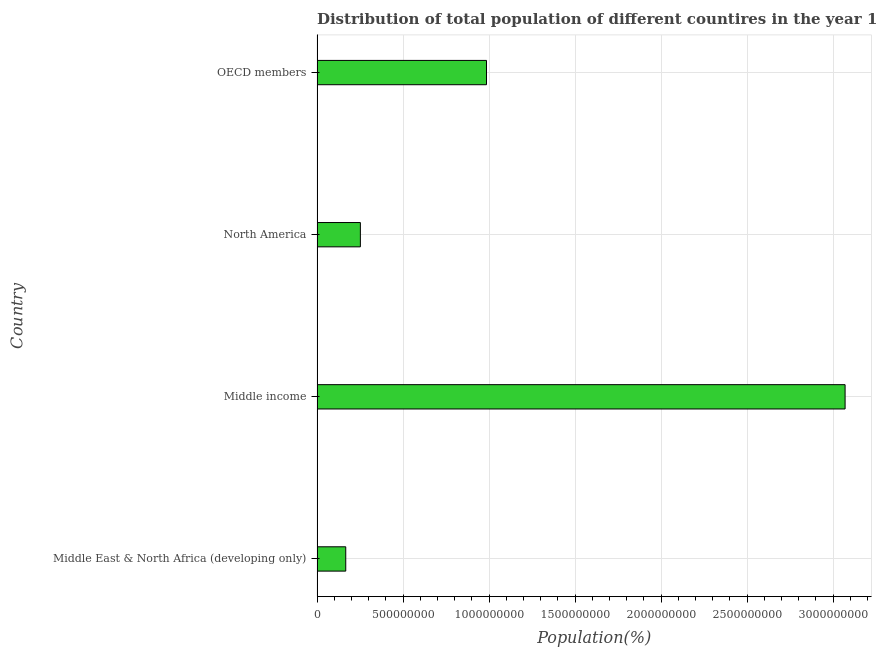Does the graph contain any zero values?
Keep it short and to the point. No. What is the title of the graph?
Offer a terse response. Distribution of total population of different countires in the year 1980. What is the label or title of the X-axis?
Your answer should be compact. Population(%). What is the label or title of the Y-axis?
Make the answer very short. Country. What is the population in Middle East & North Africa (developing only)?
Keep it short and to the point. 1.67e+08. Across all countries, what is the maximum population?
Keep it short and to the point. 3.07e+09. Across all countries, what is the minimum population?
Ensure brevity in your answer.  1.67e+08. In which country was the population minimum?
Make the answer very short. Middle East & North Africa (developing only). What is the sum of the population?
Offer a very short reply. 4.47e+09. What is the difference between the population in Middle East & North Africa (developing only) and OECD members?
Offer a very short reply. -8.18e+08. What is the average population per country?
Provide a short and direct response. 1.12e+09. What is the median population?
Keep it short and to the point. 6.19e+08. What is the ratio of the population in Middle income to that in OECD members?
Your answer should be compact. 3.12. Is the difference between the population in Middle East & North Africa (developing only) and Middle income greater than the difference between any two countries?
Make the answer very short. Yes. What is the difference between the highest and the second highest population?
Provide a succinct answer. 2.08e+09. Is the sum of the population in Middle income and North America greater than the maximum population across all countries?
Ensure brevity in your answer.  Yes. What is the difference between the highest and the lowest population?
Your answer should be compact. 2.90e+09. In how many countries, is the population greater than the average population taken over all countries?
Your answer should be compact. 1. Are all the bars in the graph horizontal?
Give a very brief answer. Yes. How many countries are there in the graph?
Provide a succinct answer. 4. What is the difference between two consecutive major ticks on the X-axis?
Make the answer very short. 5.00e+08. Are the values on the major ticks of X-axis written in scientific E-notation?
Ensure brevity in your answer.  No. What is the Population(%) in Middle East & North Africa (developing only)?
Offer a terse response. 1.67e+08. What is the Population(%) of Middle income?
Provide a succinct answer. 3.07e+09. What is the Population(%) of North America?
Offer a very short reply. 2.52e+08. What is the Population(%) of OECD members?
Offer a terse response. 9.85e+08. What is the difference between the Population(%) in Middle East & North Africa (developing only) and Middle income?
Keep it short and to the point. -2.90e+09. What is the difference between the Population(%) in Middle East & North Africa (developing only) and North America?
Keep it short and to the point. -8.50e+07. What is the difference between the Population(%) in Middle East & North Africa (developing only) and OECD members?
Offer a terse response. -8.18e+08. What is the difference between the Population(%) in Middle income and North America?
Provide a short and direct response. 2.82e+09. What is the difference between the Population(%) in Middle income and OECD members?
Give a very brief answer. 2.08e+09. What is the difference between the Population(%) in North America and OECD members?
Ensure brevity in your answer.  -7.33e+08. What is the ratio of the Population(%) in Middle East & North Africa (developing only) to that in Middle income?
Your response must be concise. 0.05. What is the ratio of the Population(%) in Middle East & North Africa (developing only) to that in North America?
Provide a succinct answer. 0.66. What is the ratio of the Population(%) in Middle East & North Africa (developing only) to that in OECD members?
Provide a succinct answer. 0.17. What is the ratio of the Population(%) in Middle income to that in North America?
Give a very brief answer. 12.19. What is the ratio of the Population(%) in Middle income to that in OECD members?
Provide a short and direct response. 3.12. What is the ratio of the Population(%) in North America to that in OECD members?
Your response must be concise. 0.26. 